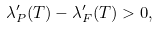<formula> <loc_0><loc_0><loc_500><loc_500>\lambda _ { P } ^ { \prime } ( T ) - \lambda _ { F } ^ { \prime } ( T ) > 0 ,</formula> 